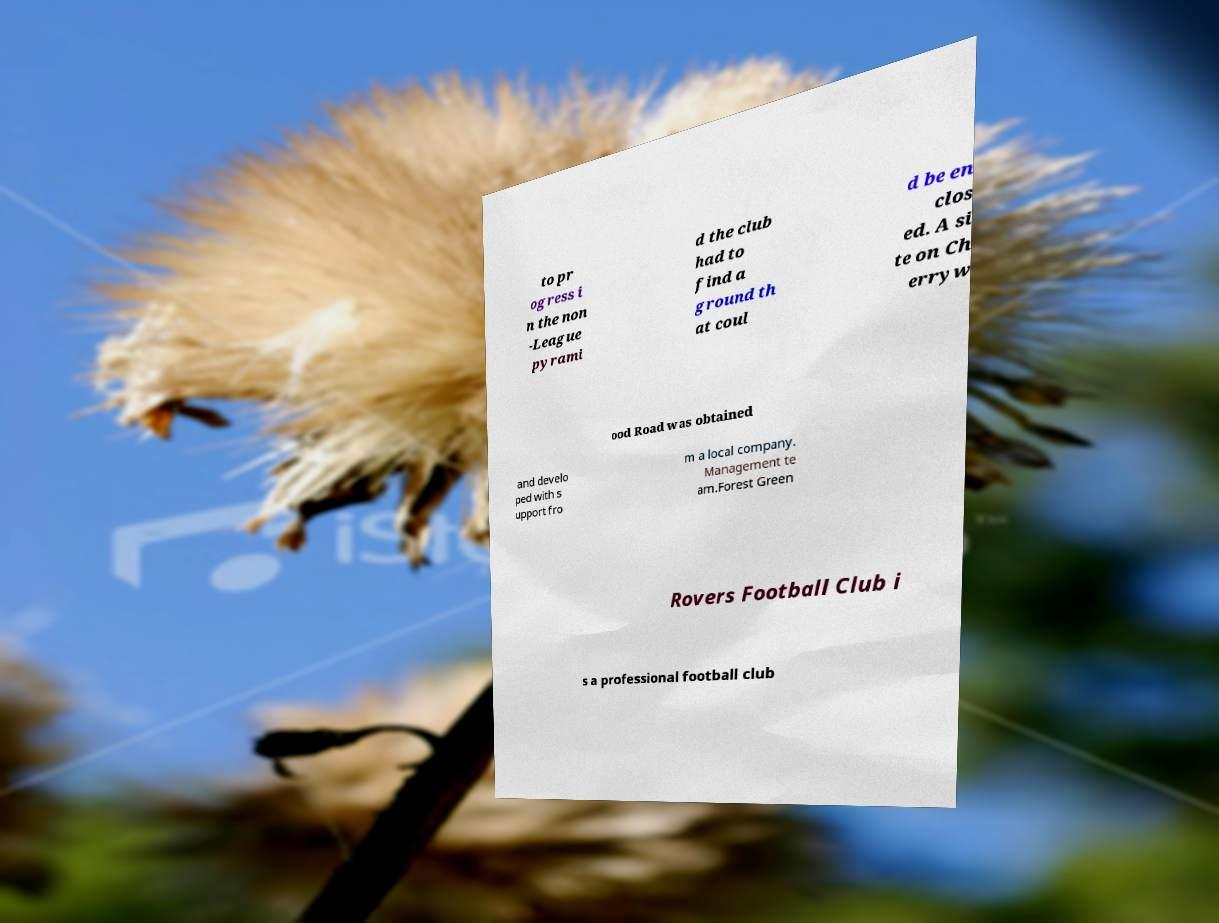What messages or text are displayed in this image? I need them in a readable, typed format. to pr ogress i n the non -League pyrami d the club had to find a ground th at coul d be en clos ed. A si te on Ch erryw ood Road was obtained and develo ped with s upport fro m a local company. Management te am.Forest Green Rovers Football Club i s a professional football club 